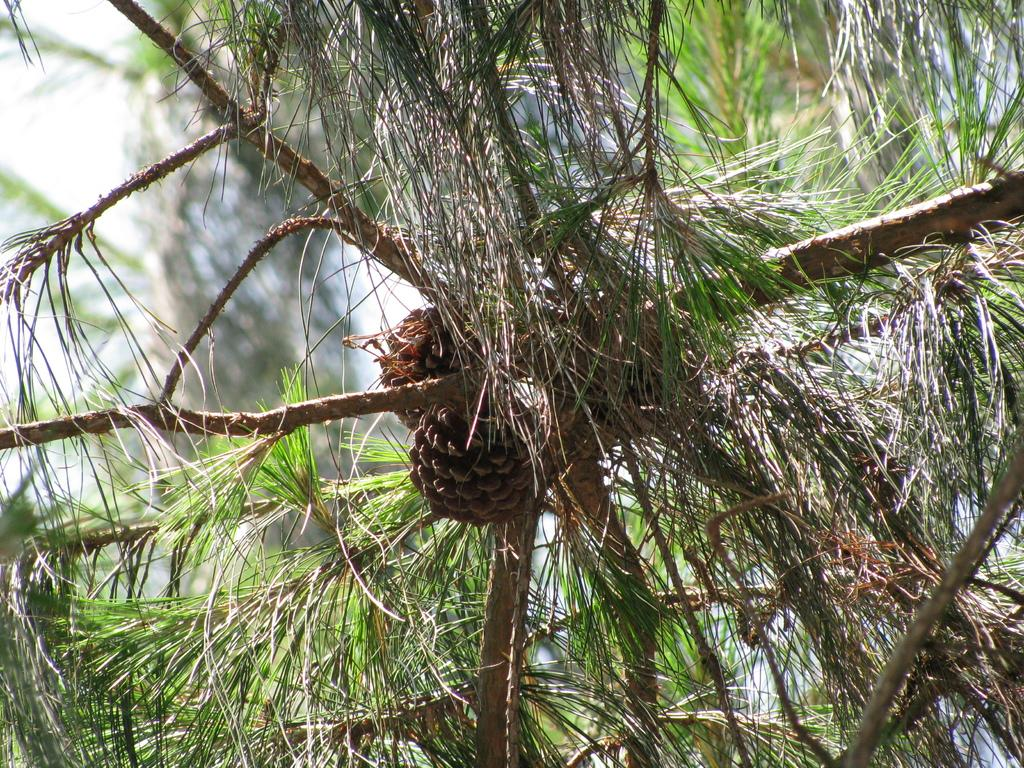What type of vegetation can be seen in the image? There are trees in the image. How would you describe the background of the image? The background of the image is blurry. Is there a pump visible in the image? There is no pump present in the image. What is the edge of the image made of? The edge of the image is not made of any material, as it is a digital representation. 